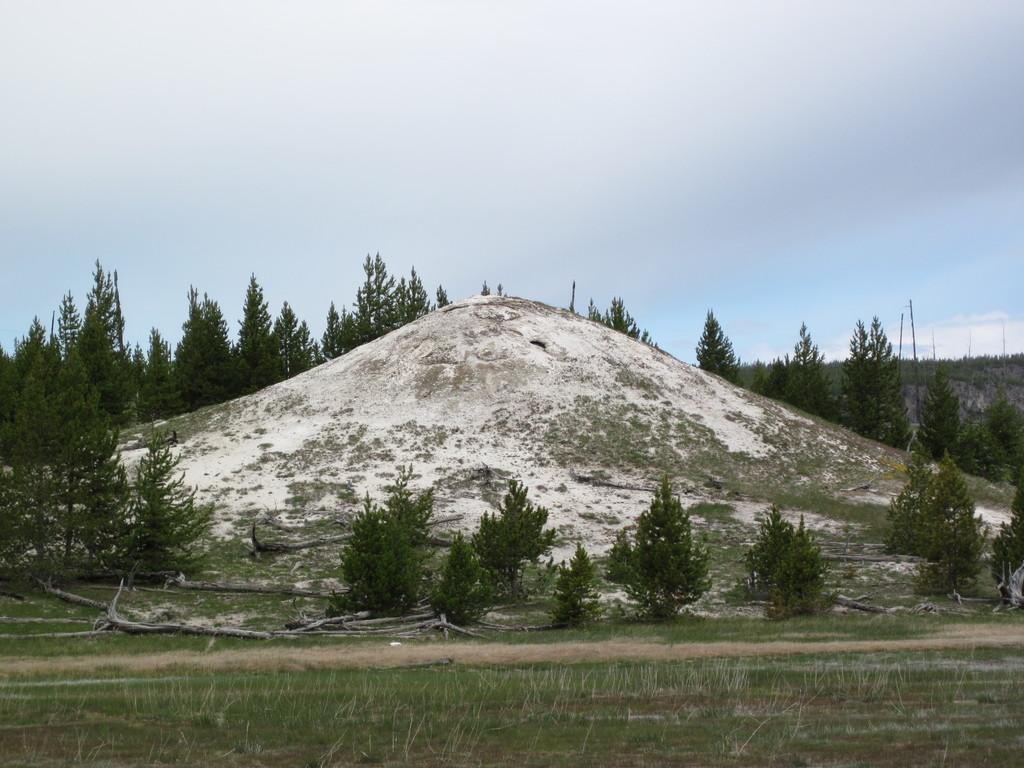How would you summarize this image in a sentence or two? In this picture we can see few sticks and grass on the ground and in the background we can see trees and the sky. 